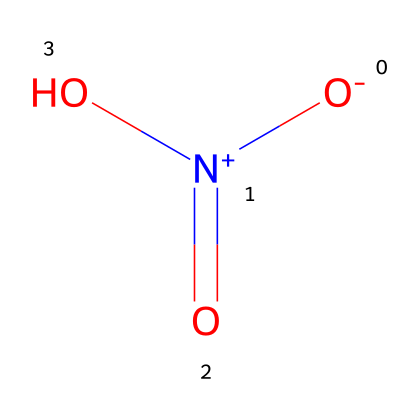What is the name of this chemical? The chemical is represented by the SMILES notation O=N(=O)O, which indicates that it is nitric acid.
Answer: nitric acid How many oxygen atoms are present in this chemical? By examining the structure represented in the SMILES notation O=N(=O)O, we see there are three oxygen atoms connected to the nitrogen and the hydroxyl group.
Answer: three What type of functional group is present in this compound? The hydroxyl group (−OH) is present in the structure shown by O=N(=O)O, indicating it belongs to the category of acids, specifically carboxylic acids due to the presence of both nitrogen and oxygen.
Answer: carboxylic acid What is the oxidation state of nitrogen in this chemical? The nitrogen atom in O=N(=O)O is bonded to two oxygen atoms with double bonds and one with a single bond, which puts its oxidation state at +5 based on its valence electron configuration.
Answer: +5 Is this chemical corrosive? Given that nitric acid (O=N(=O)O) is known for its strong acidic and corrosive properties, it is classified as corrosive.
Answer: yes 